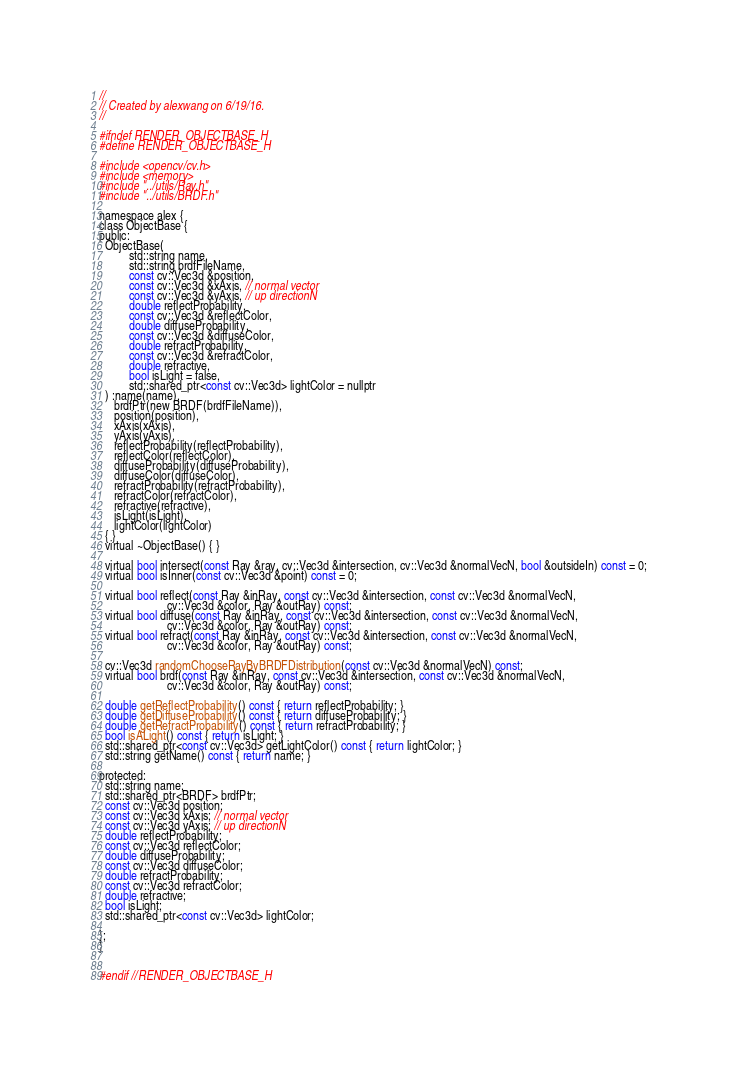<code> <loc_0><loc_0><loc_500><loc_500><_C_>//
// Created by alexwang on 6/19/16.
//

#ifndef RENDER_OBJECTBASE_H
#define RENDER_OBJECTBASE_H

#include <opencv/cv.h>
#include <memory>
#include "../utils/Ray.h"
#include "../utils/BRDF.h"

namespace alex {
class ObjectBase {
public:
  ObjectBase(
          std::string name,
          std::string brdfFileName,
          const cv::Vec3d &position,
          const cv::Vec3d &xAxis, // normal vector
          const cv::Vec3d &yAxis, // up directionN
          double reflectProbability,
          const cv::Vec3d &reflectColor,
          double diffuseProbability,
          const cv::Vec3d &diffuseColor,
          double refractProbability,
          const cv::Vec3d &refractColor,
          double refractive,
          bool isLight = false,
          std::shared_ptr<const cv::Vec3d> lightColor = nullptr
  ) :name(name),
     brdfPtr(new BRDF(brdfFileName)),
     position(position),
     xAxis(xAxis),
     yAxis(yAxis),
     reflectProbability(reflectProbability),
     reflectColor(reflectColor),
     diffuseProbability(diffuseProbability),
     diffuseColor(diffuseColor),
     refractProbability(refractProbability),
     refractColor(refractColor),
     refractive(refractive),
     isLight(isLight),
     lightColor(lightColor)
  { }
  virtual ~ObjectBase() { }

  virtual bool intersect(const Ray &ray, cv::Vec3d &intersection, cv::Vec3d &normalVecN, bool &outsideIn) const = 0;
  virtual bool isInner(const cv::Vec3d &point) const = 0;

  virtual bool reflect(const Ray &inRay, const cv::Vec3d &intersection, const cv::Vec3d &normalVecN,
                       cv::Vec3d &color, Ray &outRay) const;
  virtual bool diffuse(const Ray &inRay, const cv::Vec3d &intersection, const cv::Vec3d &normalVecN,
                       cv::Vec3d &color, Ray &outRay) const;
  virtual bool refract(const Ray &inRay, const cv::Vec3d &intersection, const cv::Vec3d &normalVecN,
                       cv::Vec3d &color, Ray &outRay) const;

  cv::Vec3d randomChooseRayByBRDFDistribution(const cv::Vec3d &normalVecN) const;
  virtual bool brdf(const Ray &inRay, const cv::Vec3d &intersection, const cv::Vec3d &normalVecN,
                       cv::Vec3d &color, Ray &outRay) const;

  double getReflectProbability() const { return reflectProbability; }
  double getDiffuseProbability() const { return diffuseProbability; }
  double getRefractProbability() const { return refractProbability; }
  bool isALight() const { return isLight; }
  std::shared_ptr<const cv::Vec3d> getLightColor() const { return lightColor; }
  std::string getName() const { return name; }

protected:
  std::string name;
  std::shared_ptr<BRDF> brdfPtr;
  const cv::Vec3d position;
  const cv::Vec3d xAxis; // normal vector
  const cv::Vec3d yAxis; // up directionN
  double reflectProbability;
  const cv::Vec3d reflectColor;
  double diffuseProbability;
  const cv::Vec3d diffuseColor;
  double refractProbability;
  const cv::Vec3d refractColor;
  double refractive;
  bool isLight;
  std::shared_ptr<const cv::Vec3d> lightColor;

};
}


#endif //RENDER_OBJECTBASE_H
</code> 